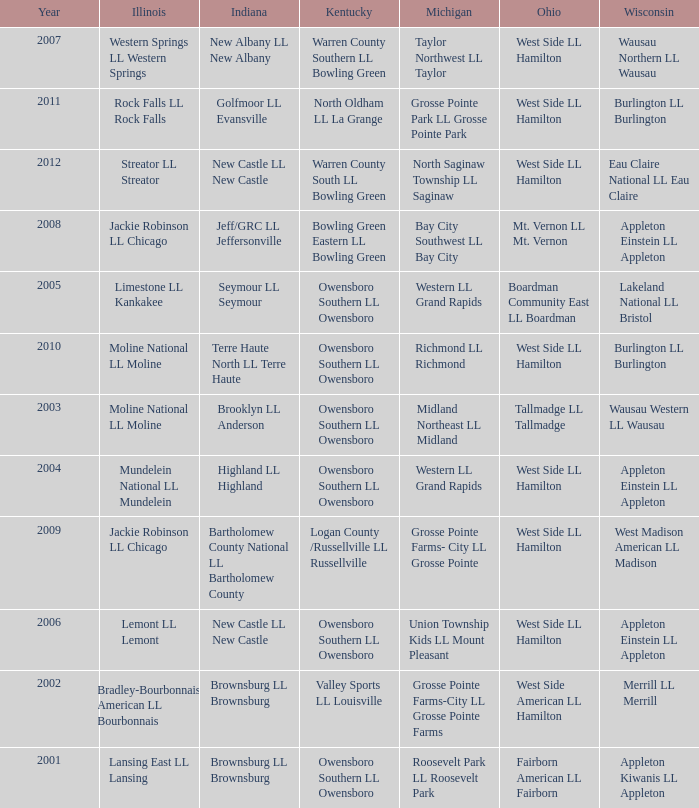Parse the full table. {'header': ['Year', 'Illinois', 'Indiana', 'Kentucky', 'Michigan', 'Ohio', 'Wisconsin'], 'rows': [['2007', 'Western Springs LL Western Springs', 'New Albany LL New Albany', 'Warren County Southern LL Bowling Green', 'Taylor Northwest LL Taylor', 'West Side LL Hamilton', 'Wausau Northern LL Wausau'], ['2011', 'Rock Falls LL Rock Falls', 'Golfmoor LL Evansville', 'North Oldham LL La Grange', 'Grosse Pointe Park LL Grosse Pointe Park', 'West Side LL Hamilton', 'Burlington LL Burlington'], ['2012', 'Streator LL Streator', 'New Castle LL New Castle', 'Warren County South LL Bowling Green', 'North Saginaw Township LL Saginaw', 'West Side LL Hamilton', 'Eau Claire National LL Eau Claire'], ['2008', 'Jackie Robinson LL Chicago', 'Jeff/GRC LL Jeffersonville', 'Bowling Green Eastern LL Bowling Green', 'Bay City Southwest LL Bay City', 'Mt. Vernon LL Mt. Vernon', 'Appleton Einstein LL Appleton'], ['2005', 'Limestone LL Kankakee', 'Seymour LL Seymour', 'Owensboro Southern LL Owensboro', 'Western LL Grand Rapids', 'Boardman Community East LL Boardman', 'Lakeland National LL Bristol'], ['2010', 'Moline National LL Moline', 'Terre Haute North LL Terre Haute', 'Owensboro Southern LL Owensboro', 'Richmond LL Richmond', 'West Side LL Hamilton', 'Burlington LL Burlington'], ['2003', 'Moline National LL Moline', 'Brooklyn LL Anderson', 'Owensboro Southern LL Owensboro', 'Midland Northeast LL Midland', 'Tallmadge LL Tallmadge', 'Wausau Western LL Wausau'], ['2004', 'Mundelein National LL Mundelein', 'Highland LL Highland', 'Owensboro Southern LL Owensboro', 'Western LL Grand Rapids', 'West Side LL Hamilton', 'Appleton Einstein LL Appleton'], ['2009', 'Jackie Robinson LL Chicago', 'Bartholomew County National LL Bartholomew County', 'Logan County /Russellville LL Russellville', 'Grosse Pointe Farms- City LL Grosse Pointe', 'West Side LL Hamilton', 'West Madison American LL Madison'], ['2006', 'Lemont LL Lemont', 'New Castle LL New Castle', 'Owensboro Southern LL Owensboro', 'Union Township Kids LL Mount Pleasant', 'West Side LL Hamilton', 'Appleton Einstein LL Appleton'], ['2002', 'Bradley-Bourbonnais American LL Bourbonnais', 'Brownsburg LL Brownsburg', 'Valley Sports LL Louisville', 'Grosse Pointe Farms-City LL Grosse Pointe Farms', 'West Side American LL Hamilton', 'Merrill LL Merrill'], ['2001', 'Lansing East LL Lansing', 'Brownsburg LL Brownsburg', 'Owensboro Southern LL Owensboro', 'Roosevelt Park LL Roosevelt Park', 'Fairborn American LL Fairborn', 'Appleton Kiwanis LL Appleton']]} What was the little league team from Kentucky when the little league team from Illinois was Rock Falls LL Rock Falls? North Oldham LL La Grange. 